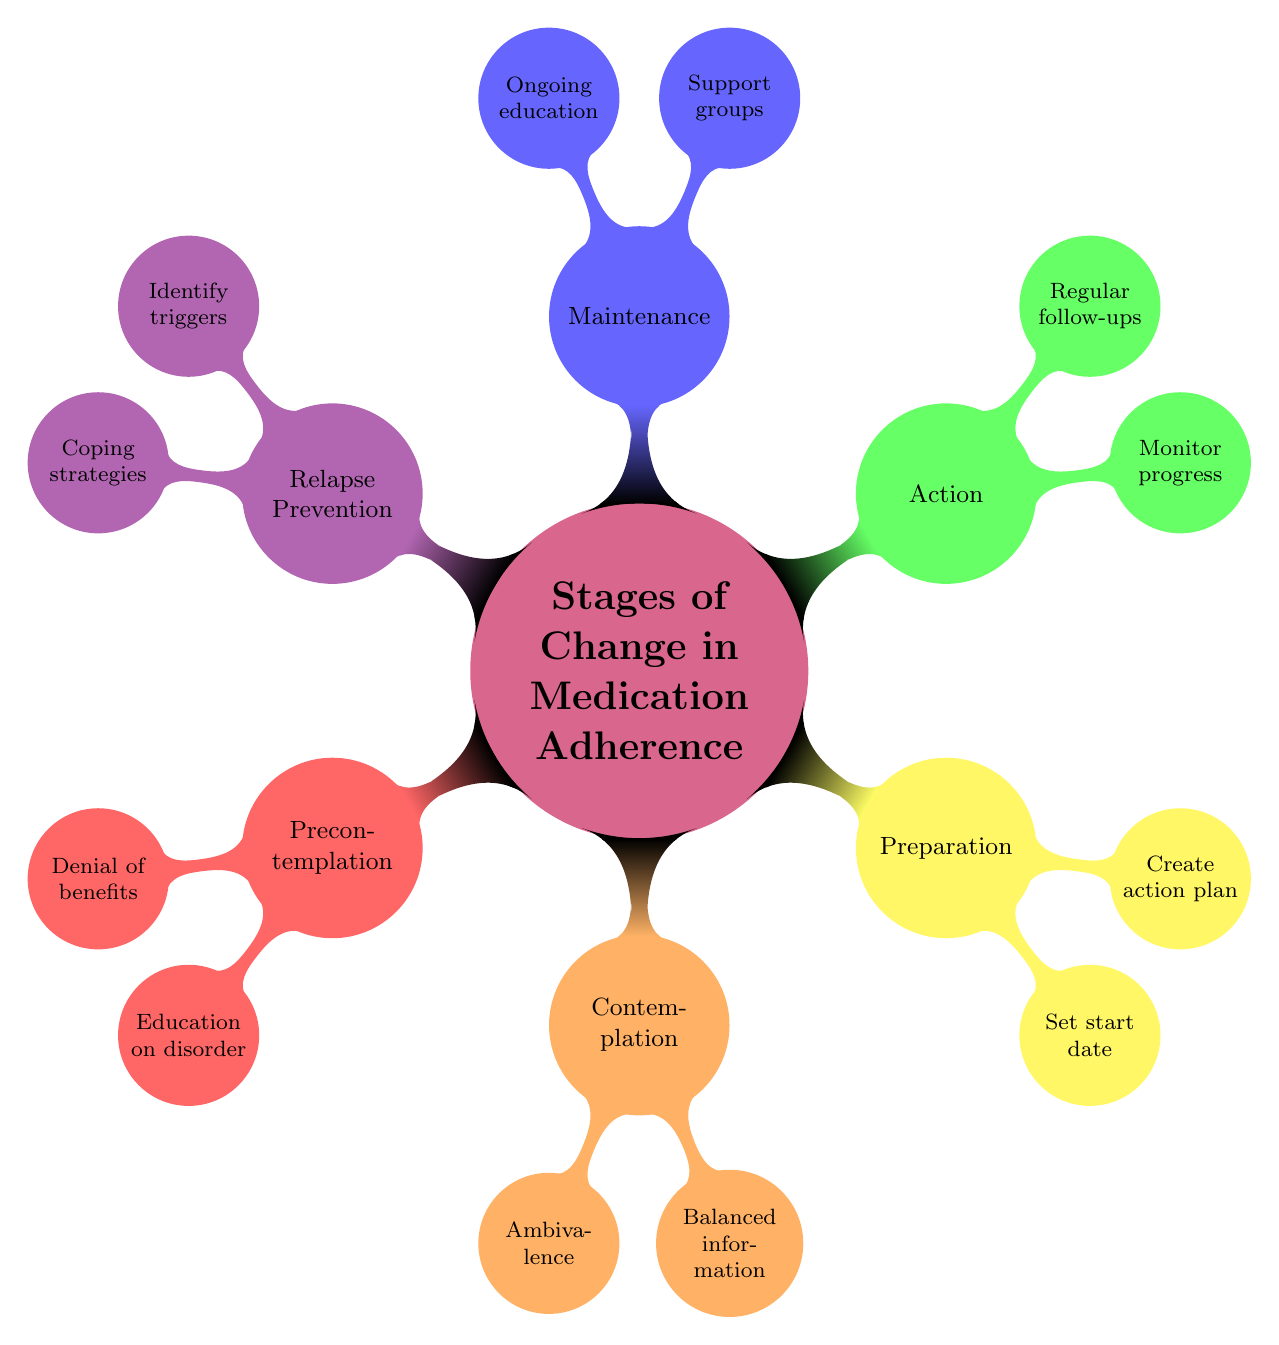What is the first stage in the diagram? According to the structure of the mind map, the first stage listed under "Stages of Change in Medication Adherence" is "Precontemplation." This can be directly seen as the first node branching out from the central concept.
Answer: Precontemplation What strategy is associated with the Maintenance stage? The "Maintenance" stage node has two strategies listed below it. One of the strategies is "Support groups," which can be identified under the Maintenance section of the diagram.
Answer: Support groups How many challenges are listed for the Action stage? Under the "Action" stage, there are two challenges specified, which are "Initial side effects" and "Establishing a routine." These are directly connected to the Action node.
Answer: 2 Which stage involves creating an action plan? The stage that involves creating an action plan is "Preparation." This is specifically mentioned as one of the strategies associated with the Preparation stage in the mind map.
Answer: Preparation What challenge is associated with the Contemplation stage? One of the challenges listed under the "Contemplation" stage is "Ambivalence." This is shown as a child node branching from the Contemplation node within the mind map.
Answer: Ambivalence What is a key focus during the Relapse Prevention stage? The key focus during the "Relapse Prevention" stage is to "Identify triggers." This information is found directly under the Relapse Prevention node as one of its strategies.
Answer: Identify triggers How many stages are represented in the mind map? The mind map visually represents a total of six stages, as indicated by each main branch extending from the central concept of "Stages of Change in Medication Adherence."
Answer: 6 Which stage addresses the need for education on the disorder? The "Precontemplation" stage addresses the need for education on the disorder, with "Education on disorder" being one of its strategies, as shown in the diagram.
Answer: Precontemplation What is one challenge noted in the Maintenance stage? One challenge noted in the "Maintenance" stage is "Sustaining motivation." This information can be found directly below the Maintenance node in the mind map.
Answer: Sustaining motivation 